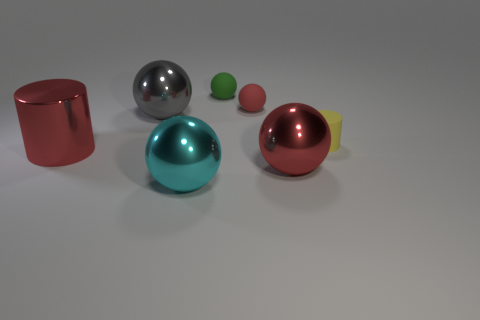Subtract all cyan cylinders. How many red balls are left? 2 Subtract all large red metallic spheres. How many spheres are left? 4 Subtract all green balls. How many balls are left? 4 Add 1 gray shiny objects. How many objects exist? 8 Subtract 2 spheres. How many spheres are left? 3 Subtract all cylinders. How many objects are left? 5 Add 7 shiny spheres. How many shiny spheres are left? 10 Add 7 tiny yellow objects. How many tiny yellow objects exist? 8 Subtract 1 gray balls. How many objects are left? 6 Subtract all cyan balls. Subtract all purple cubes. How many balls are left? 4 